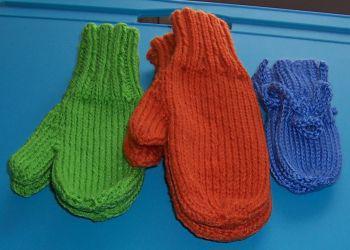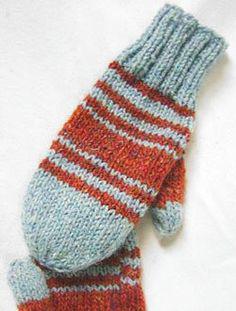The first image is the image on the left, the second image is the image on the right. Given the left and right images, does the statement "There is at least one pair of gloves with the both thumb parts pointing right." hold true? Answer yes or no. No. The first image is the image on the left, the second image is the image on the right. Given the left and right images, does the statement "Each image contains exactly one mitten pair, and all mittens feature reddish-orange color." hold true? Answer yes or no. No. 